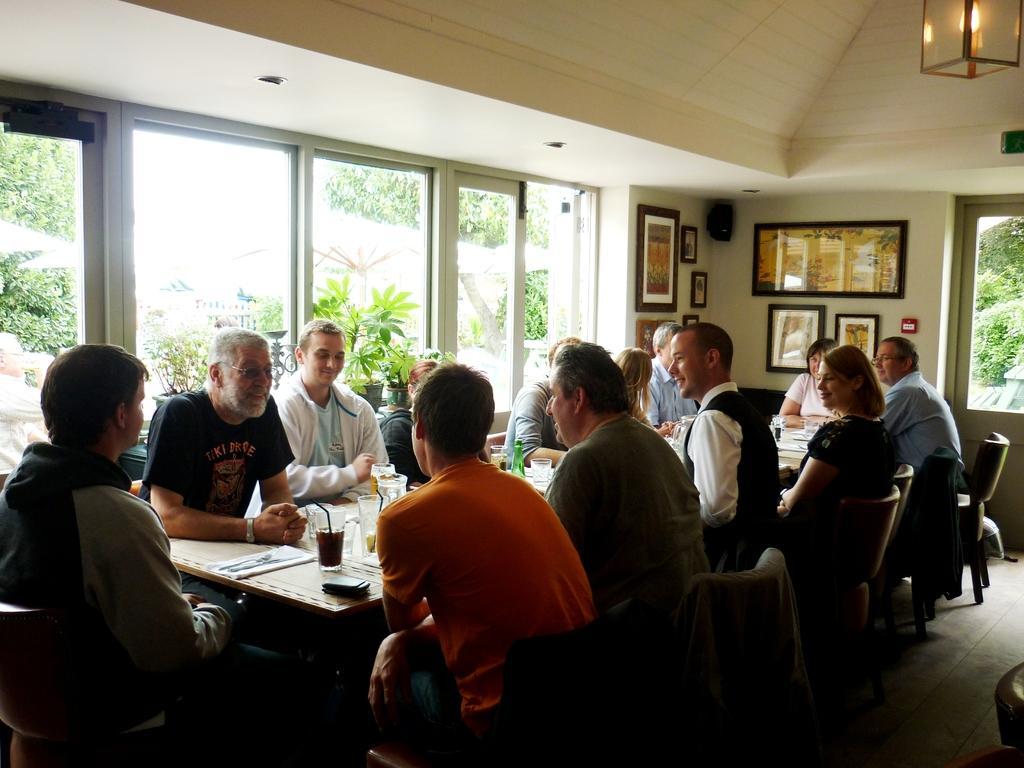Please provide a concise description of this image. It is a restaurant, group of people are sitting together some glasses and drinks are kept on the table in between them,to the right side to the wall there are lot of photos, in the background there are some windows, behind the windows few trees and plants. 